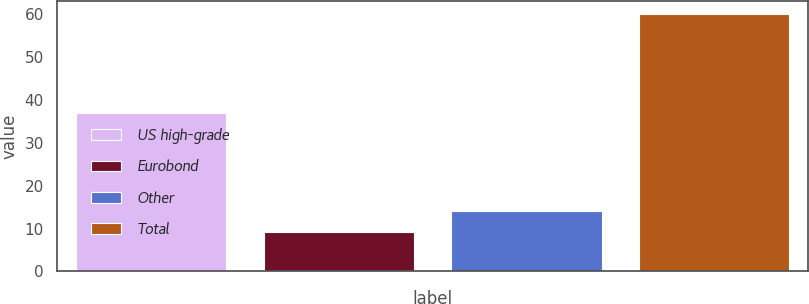Convert chart to OTSL. <chart><loc_0><loc_0><loc_500><loc_500><bar_chart><fcel>US high-grade<fcel>Eurobond<fcel>Other<fcel>Total<nl><fcel>36.8<fcel>9.1<fcel>14.19<fcel>60<nl></chart> 